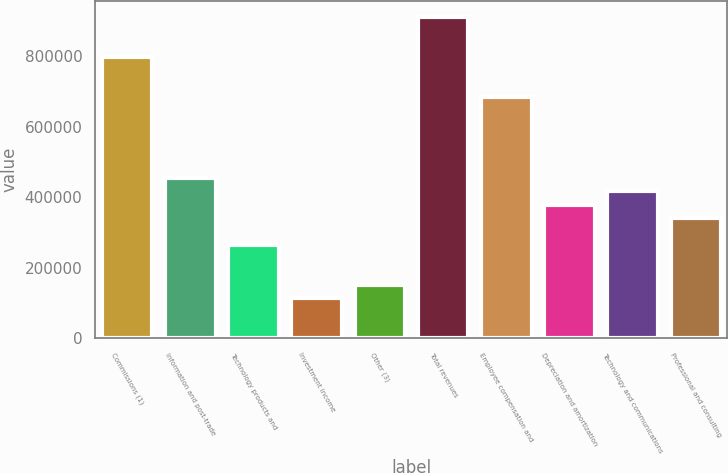Convert chart. <chart><loc_0><loc_0><loc_500><loc_500><bar_chart><fcel>Commissions (1)<fcel>Information and post-trade<fcel>Technology products and<fcel>Investment income<fcel>Other (3)<fcel>Total revenues<fcel>Employee compensation and<fcel>Depreciation and amortization<fcel>Technology and communications<fcel>Professional and consulting<nl><fcel>797756<fcel>455861<fcel>265919<fcel>113966<fcel>151954<fcel>911721<fcel>683791<fcel>379884<fcel>417872<fcel>341896<nl></chart> 